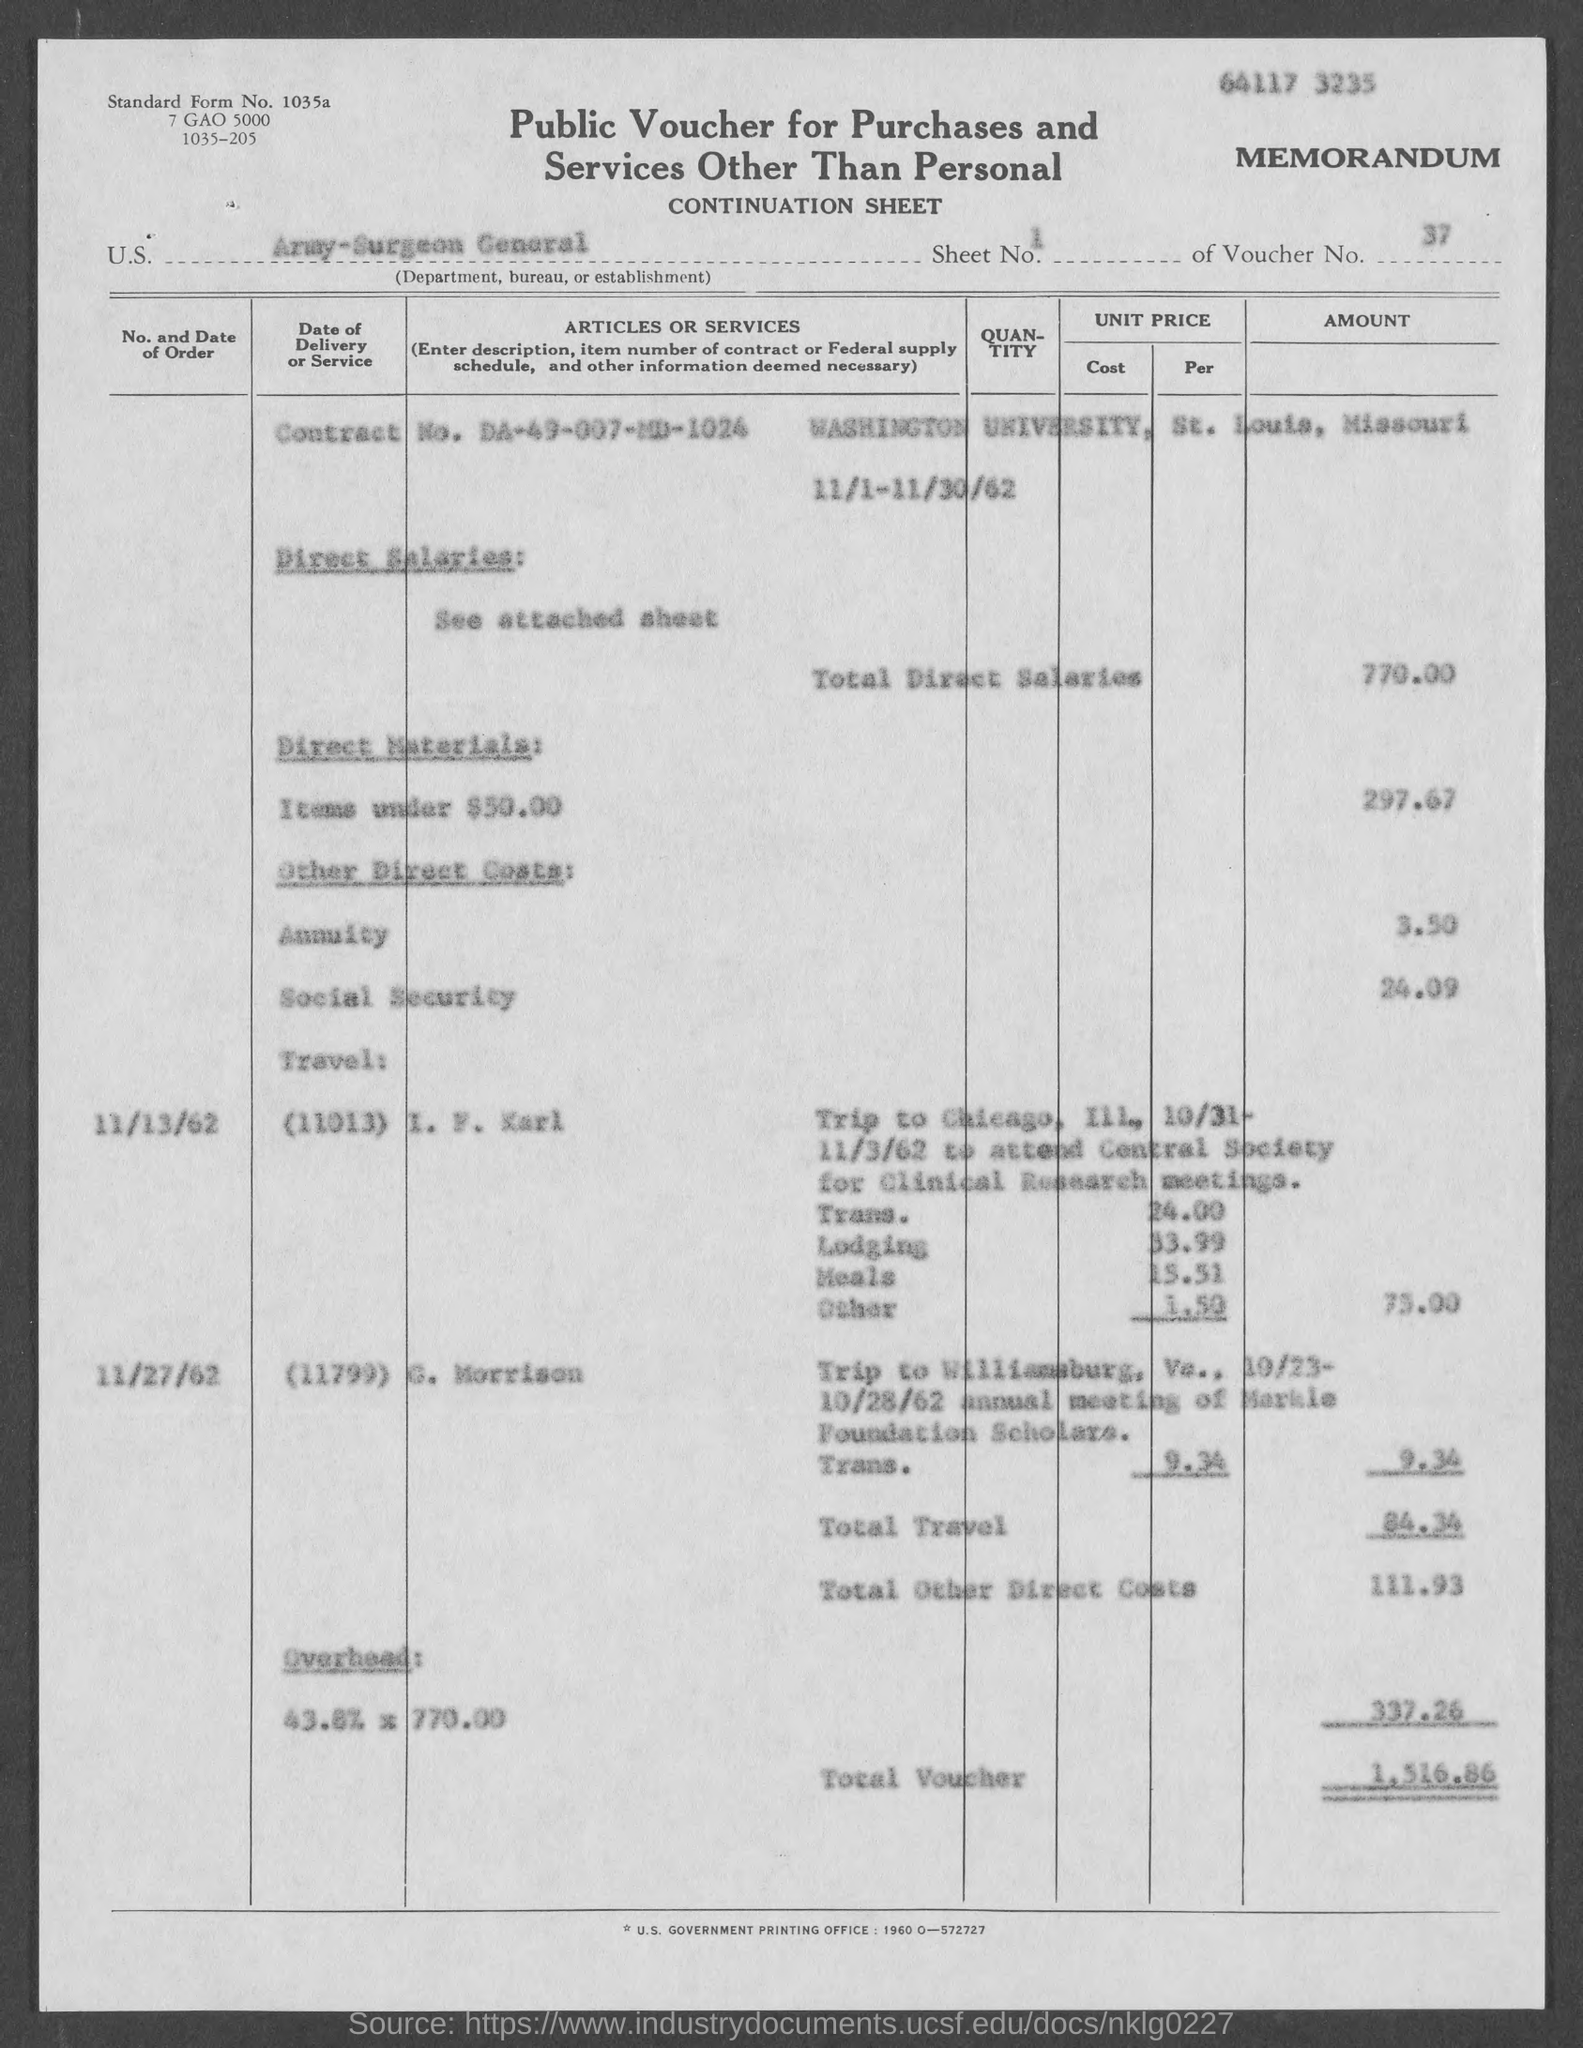Can you tell me what the total voucher amount is on this document? Certainly! The total voucher amount indicated on the document is $1,516.86. 